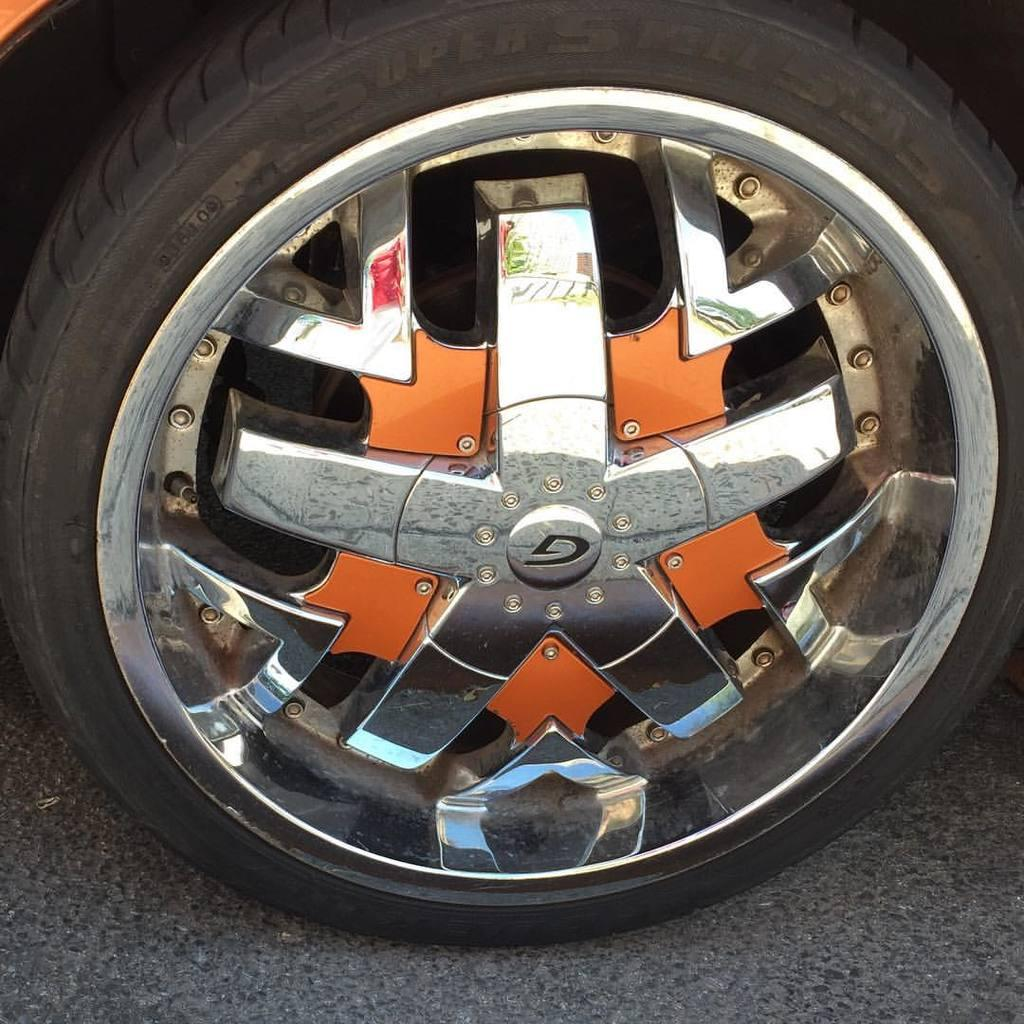What object is present on the ground in the image? There is a tire on the ground in the image. What type of quartz can be seen in the image? There is no quartz present in the image; it features a tire on the ground. What does the mom in the image say to the child? There is no mom or child present in the image, as it only features a tire on the ground. 